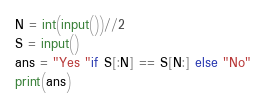<code> <loc_0><loc_0><loc_500><loc_500><_Python_>N = int(input())//2
S = input()
ans = "Yes "if S[:N] == S[N:] else "No"
print(ans)</code> 